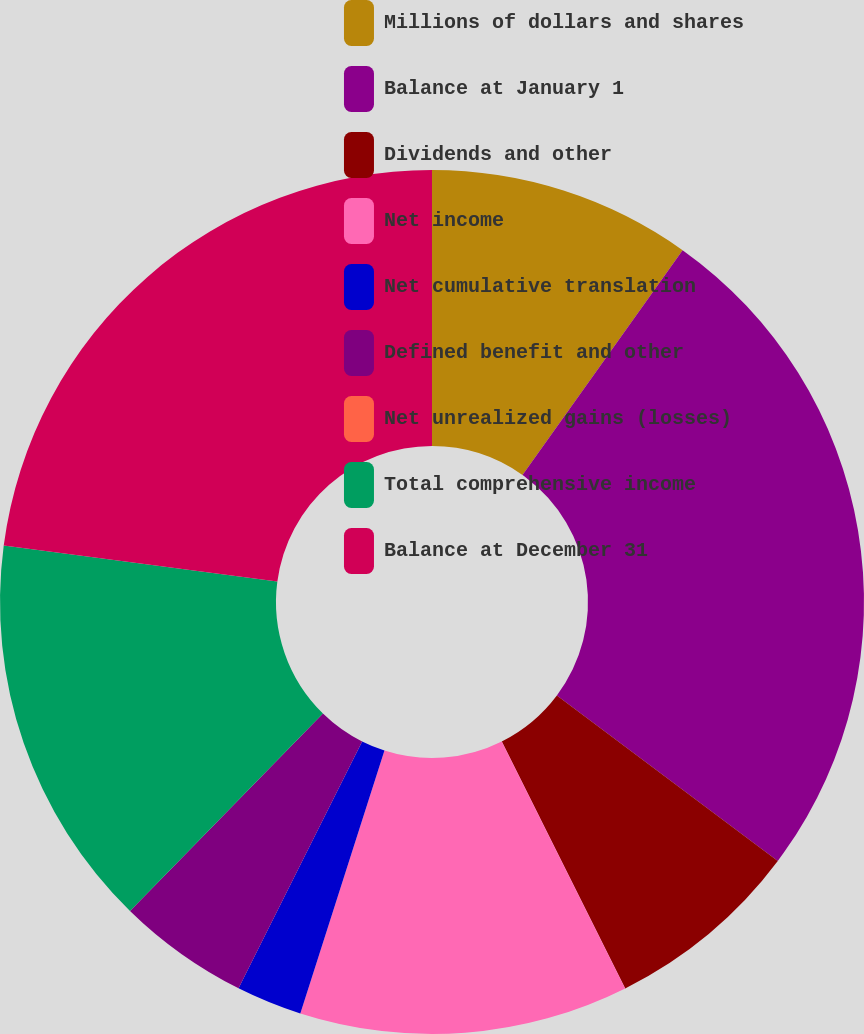Convert chart. <chart><loc_0><loc_0><loc_500><loc_500><pie_chart><fcel>Millions of dollars and shares<fcel>Balance at January 1<fcel>Dividends and other<fcel>Net income<fcel>Net cumulative translation<fcel>Defined benefit and other<fcel>Net unrealized gains (losses)<fcel>Total comprehensive income<fcel>Balance at December 31<nl><fcel>9.85%<fcel>25.38%<fcel>7.39%<fcel>12.31%<fcel>2.46%<fcel>4.93%<fcel>0.0%<fcel>14.77%<fcel>22.91%<nl></chart> 